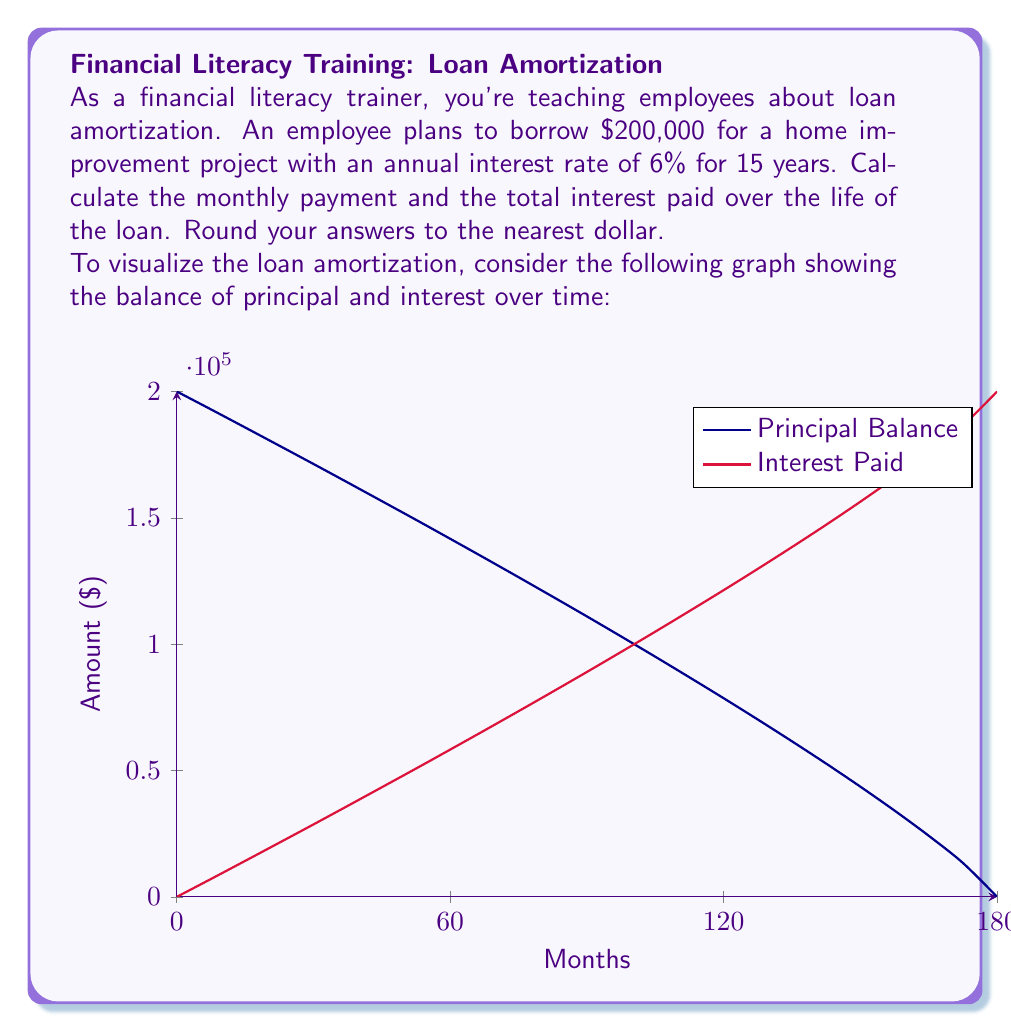Provide a solution to this math problem. To solve this problem, we'll use the loan amortization formula and calculate the total interest paid.

Step 1: Calculate the monthly payment using the loan amortization formula:
$$P = L\frac{r(1+r)^n}{(1+r)^n-1}$$

Where:
$P$ = Monthly payment
$L$ = Loan amount ($200,000)
$r$ = Monthly interest rate (6% / 12 = 0.5% = 0.005)
$n$ = Total number of months (15 years * 12 = 180 months)

$$P = 200000\frac{0.005(1+0.005)^{180}}{(1+0.005)^{180}-1}$$
$$P = 1687.71$$

Step 2: Round the monthly payment to the nearest dollar:
$P = $1,688

Step 3: Calculate the total amount paid over the life of the loan:
Total Paid = Monthly Payment * Number of Months
$$\text{Total Paid} = 1688 * 180 = $303,840$$

Step 4: Calculate the total interest paid:
Total Interest = Total Paid - Original Loan Amount
$$\text{Total Interest} = 303,840 - 200,000 = $103,840$$

Therefore, the monthly payment is $1,688, and the total interest paid over the life of the loan is $103,840.
Answer: Monthly payment: $1,688; Total interest paid: $103,840 